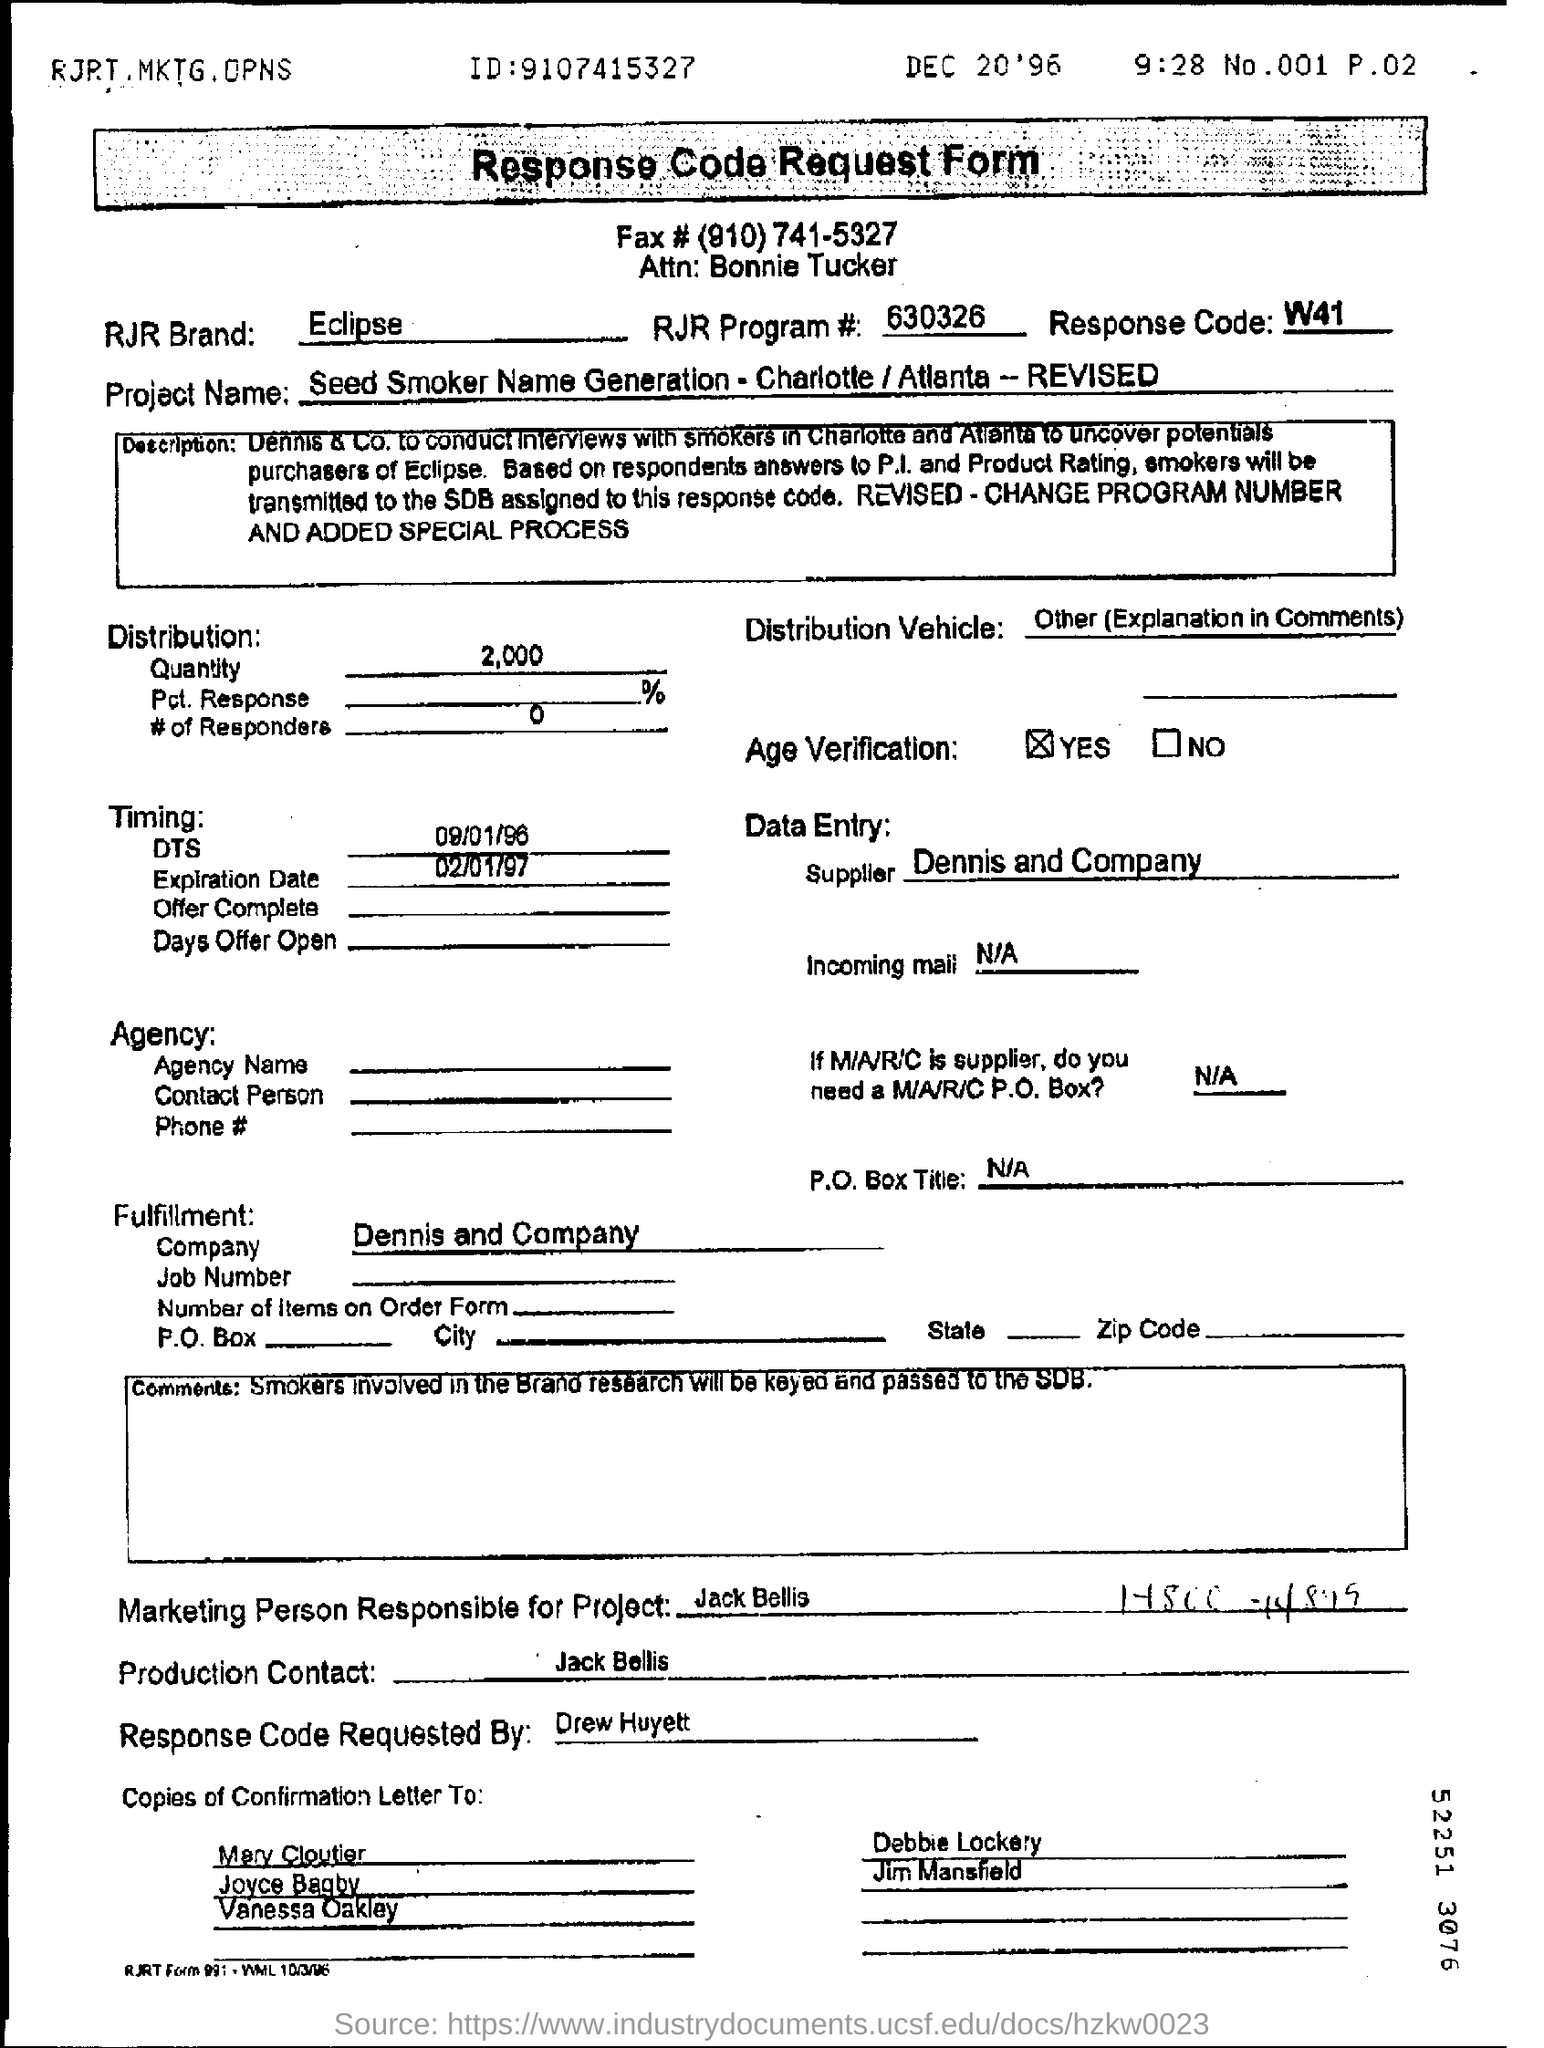Who is the marketing person responsible for this ?
Provide a short and direct response. Jack Bellis. Who requested Response Code ?
Keep it short and to the point. Drew Huyett. What is the Response code ?
Provide a succinct answer. W41. What is RJR program number ?
Your answer should be very brief. 630326. 